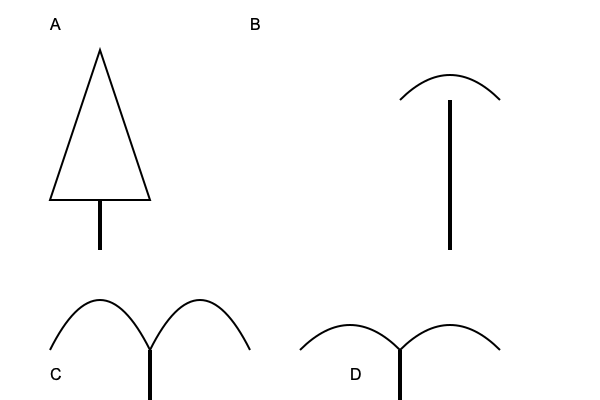Match the following tree silhouettes to their corresponding species: Oak, Maple, Pine, and Palm. Which letter corresponds to the Oak tree? To identify the Oak tree silhouette, let's analyze each tree's characteristics:

1. Tree A (top-left): This tree has a triangular shape with a pointed top, characteristic of coniferous trees. This is likely a Pine tree.

2. Tree B (top-right): This tree has a single straight trunk with a fan-like arrangement of leaves at the top. This is typical of a Palm tree.

3. Tree C (bottom-left): This tree has a broad, rounded crown with irregular, wavy edges. The trunk is thick and sturdy. These features are characteristic of an Oak tree.

4. Tree D (bottom-right): This tree has a rounded crown with a more symmetrical shape compared to the Oak. The edges are smoother, which is typical of a Maple tree.

Based on these observations, we can conclude that the Oak tree is represented by the silhouette labeled C.
Answer: C 